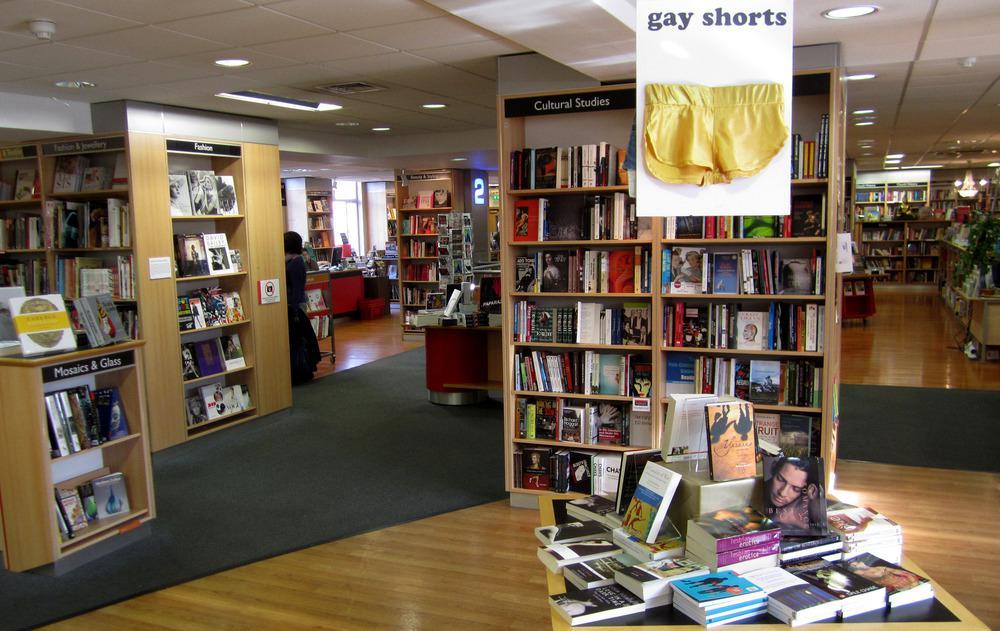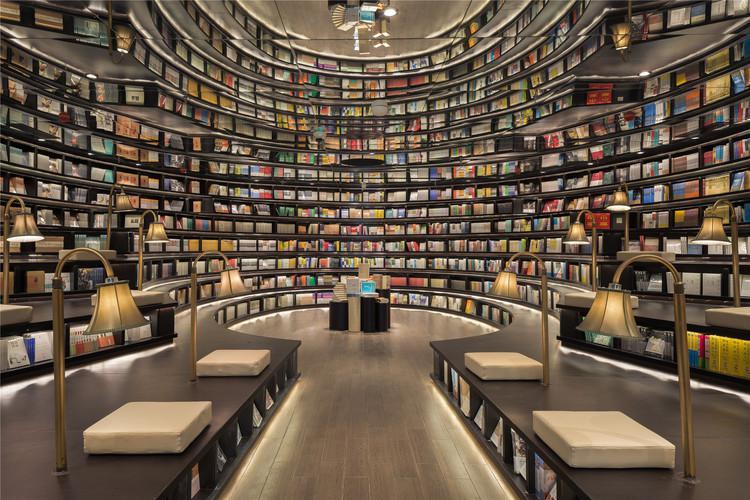The first image is the image on the left, the second image is the image on the right. For the images shown, is this caption "There is at least one person in the image on the left." true? Answer yes or no. No. The first image is the image on the left, the second image is the image on the right. Considering the images on both sides, is "One image shows a seating area in a book store." valid? Answer yes or no. Yes. 